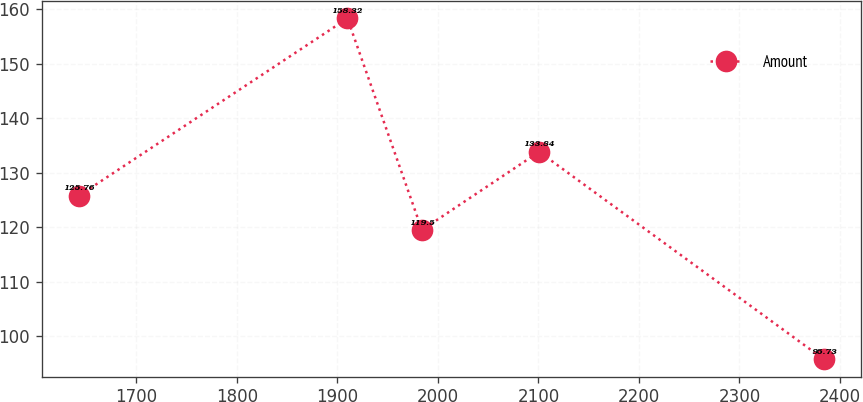Convert chart to OTSL. <chart><loc_0><loc_0><loc_500><loc_500><line_chart><ecel><fcel>Amount<nl><fcel>1642.76<fcel>125.76<nl><fcel>1910.01<fcel>158.32<nl><fcel>1984.16<fcel>119.5<nl><fcel>2100.77<fcel>133.84<nl><fcel>2384.24<fcel>95.73<nl></chart> 